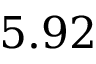<formula> <loc_0><loc_0><loc_500><loc_500>5 . 9 2</formula> 